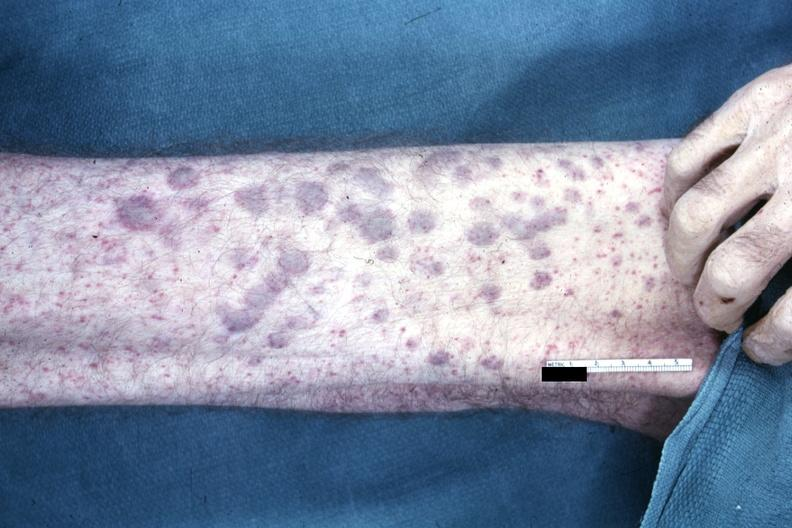s teeth said to be aml infiltrates?
Answer the question using a single word or phrase. No 